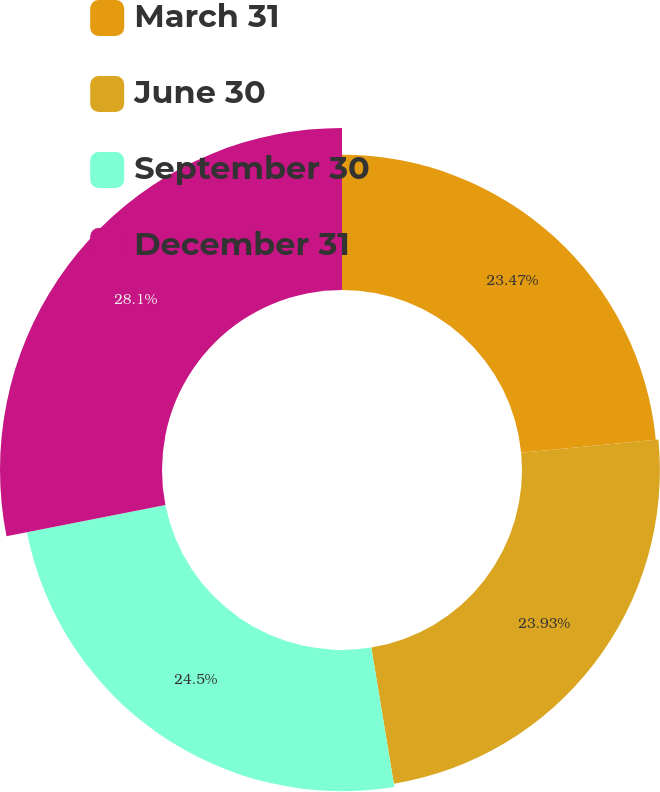<chart> <loc_0><loc_0><loc_500><loc_500><pie_chart><fcel>March 31<fcel>June 30<fcel>September 30<fcel>December 31<nl><fcel>23.47%<fcel>23.93%<fcel>24.5%<fcel>28.11%<nl></chart> 